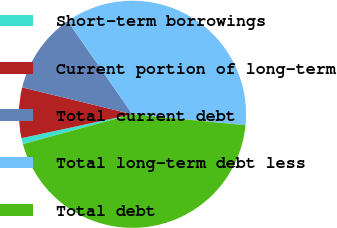Convert chart. <chart><loc_0><loc_0><loc_500><loc_500><pie_chart><fcel>Short-term borrowings<fcel>Current portion of long-term<fcel>Total current debt<fcel>Total long-term debt less<fcel>Total debt<nl><fcel>0.86%<fcel>7.18%<fcel>11.52%<fcel>36.2%<fcel>44.24%<nl></chart> 